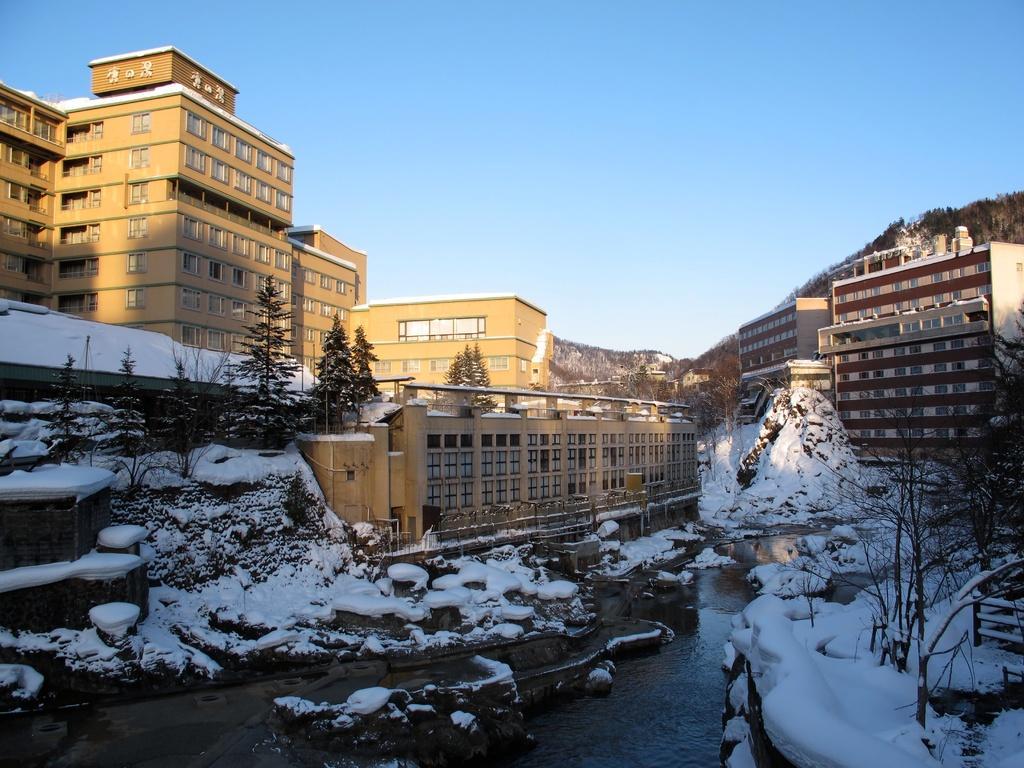In one or two sentences, can you explain what this image depicts? In this picture we can observe snow on the land. We can observe some water. There are some trees in this picture. We can observe buildings which were in yellow and maroon color. In the background there is a hill and a sky. 